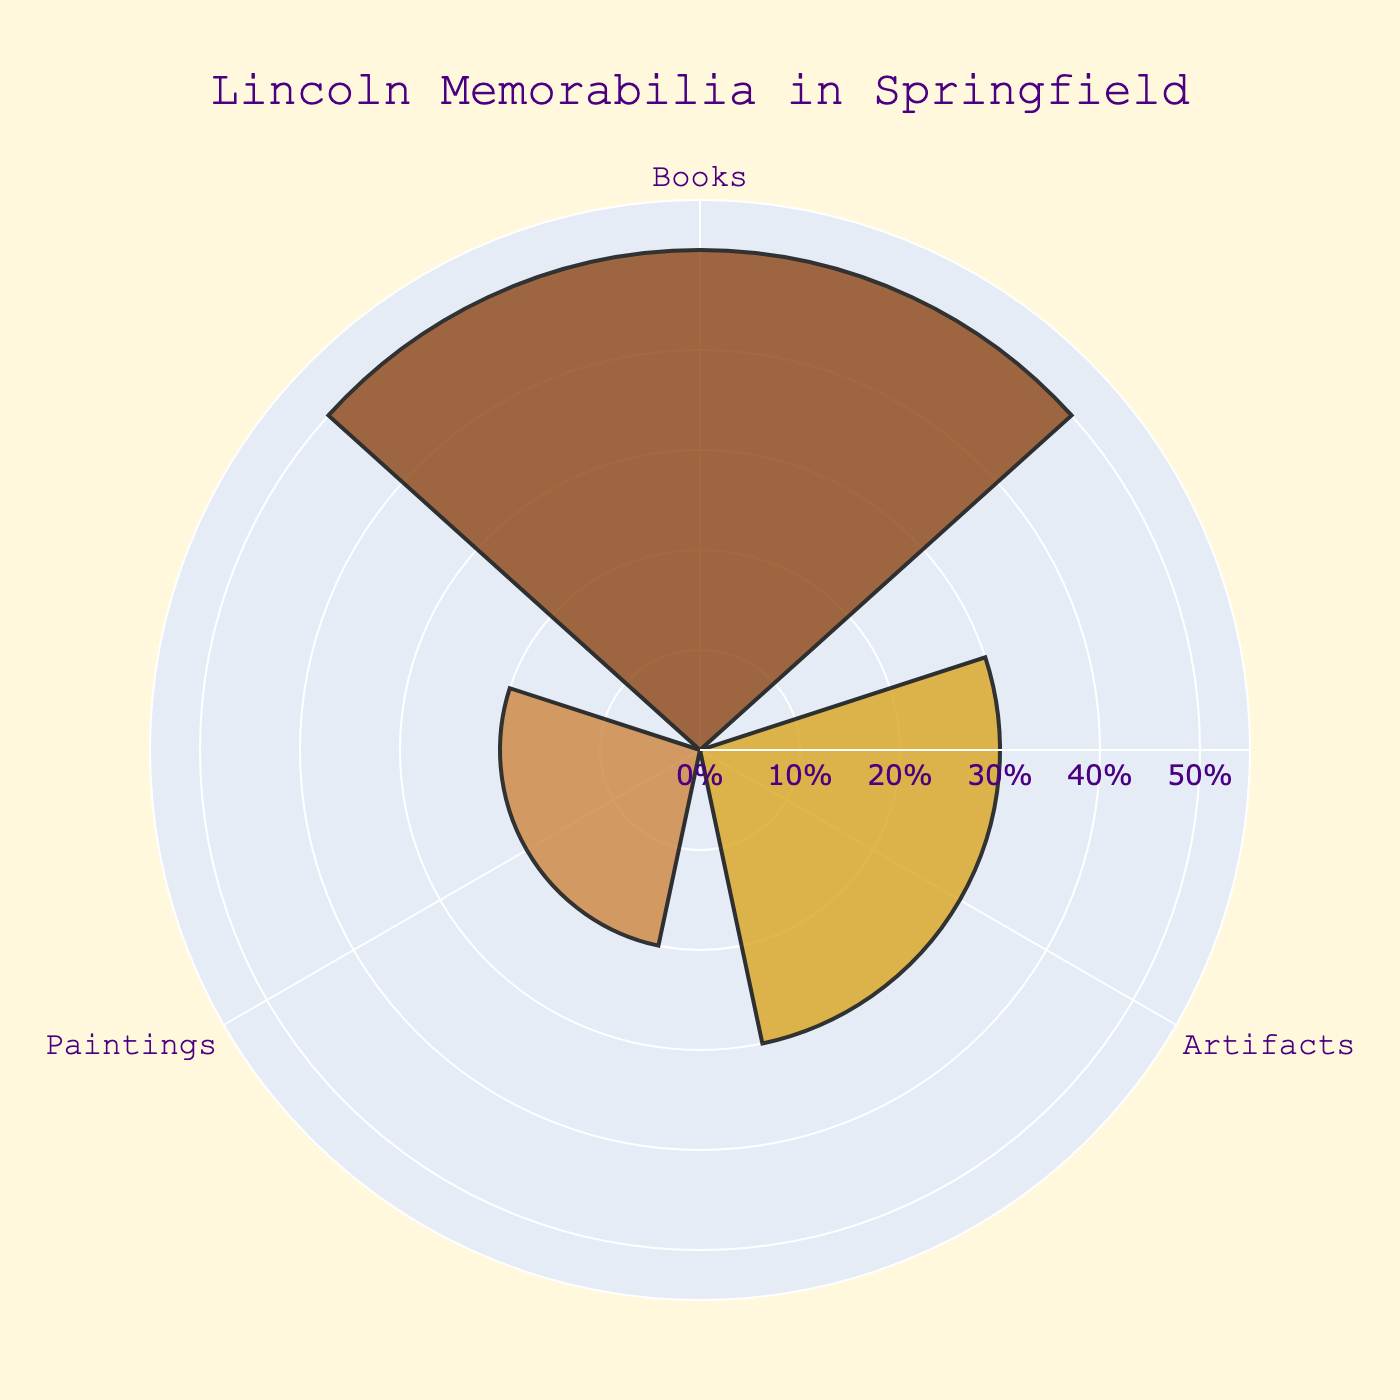Which Lincoln memorabilia type has the highest proportion? The figure shows that Books have the highest proportion among the types of Lincoln memorabilia. The bar indicating Books reaches the highest value on the radial axis.
Answer: Books What colors are used to represent the different types of Lincoln memorabilia? The figure uses brown shades to represent the different types: Books are a dark brown, Artifacts are a golden brown, and Paintings are a tan brown.
Answer: Dark brown, golden brown, tan brown What is the title of the chart? The title is displayed prominently at the top of the figure. It clearly states, "Lincoln Memorabilia in Springfield".
Answer: Lincoln Memorabilia in Springfield Which Lincoln memorabilia type has the lowest proportion? The bar corresponding to Paintings reaches the lowest value on the radial axis, indicating it has the lowest proportion.
Answer: Paintings How does the proportion of Books compare to the total proportion of Artifacts and Paintings? Books have a proportion of 50%. Artifacts and Paintings together make up 30% + 20% = 50%. Hence, Books have an equal proportion compared to the combined total of Artifacts and Paintings.
Answer: Equal What is the range of the radial axis in the chart? The range of the radial axis can be observed to go from 0 to 55%, as indicated by the marked values and slight extension beyond the maximum proportion of 50%.
Answer: 0 to 55% By how much does the proportion of Artifacts exceed the proportion of Paintings? The proportion of Artifacts is 30%, and the proportion of Paintings is 20%. The difference is 30% - 20% = 10%.
Answer: 10% What proportion of Lincoln memorabilia is not Books? Total proportion is 100%. Subtract the proportion of Books (50%) to find the remaining proportion (Artifacts + Paintings). Thus, it's 100% - 50% = 50%.
Answer: 50% How is the angular axis labeled in this chart? The angular axis is labeled with the types of memorabilia: Books, Artifacts, Paintings. Each type is displayed around the chart at equal angular intervals.
Answer: Books, Artifacts, Paintings 